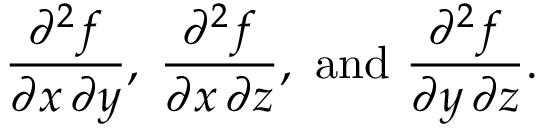Convert formula to latex. <formula><loc_0><loc_0><loc_500><loc_500>{ \frac { \partial ^ { 2 } f } { \partial x \, \partial y } } , \, { \frac { \partial ^ { 2 } f } { \partial x \, \partial z } } , { a n d } { \frac { \partial ^ { 2 } f } { \partial y \, \partial z } } .</formula> 